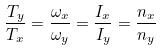<formula> <loc_0><loc_0><loc_500><loc_500>\frac { T _ { y } } { T _ { x } } = \frac { \omega _ { x } } { \omega _ { y } } = \frac { I _ { x } } { I _ { y } } = \frac { n _ { x } } { n _ { y } }</formula> 